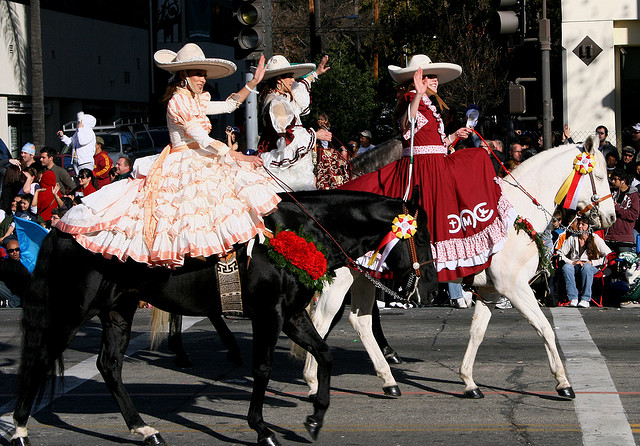Please extract the text content from this image. M 